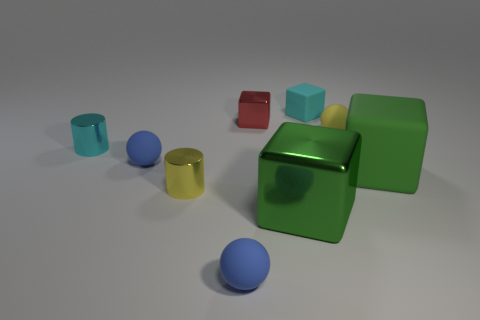What is the ball that is right of the tiny cube behind the red metal cube made of?
Your answer should be compact. Rubber. Do the green shiny cube and the green rubber object have the same size?
Provide a succinct answer. Yes. What number of small objects are either green shiny things or blue things?
Give a very brief answer. 2. How many red metallic objects are behind the small yellow rubber thing?
Offer a very short reply. 1. Are there more big rubber blocks that are behind the tiny cyan matte object than small yellow metal things?
Keep it short and to the point. No. The large green object that is made of the same material as the yellow sphere is what shape?
Provide a short and direct response. Cube. The big matte thing behind the shiny cylinder that is right of the small cyan cylinder is what color?
Your answer should be compact. Green. Does the red object have the same shape as the yellow rubber thing?
Give a very brief answer. No. There is a red thing that is the same shape as the green metal thing; what material is it?
Your answer should be very brief. Metal. There is a rubber block that is to the right of the cyan object that is on the right side of the yellow metal cylinder; are there any tiny yellow metallic cylinders that are to the right of it?
Offer a terse response. No. 